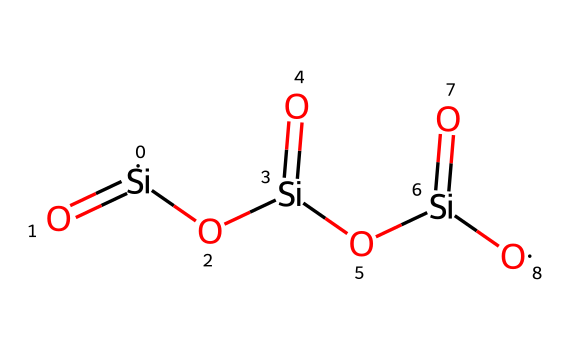What is the chemical name of this compound? The SMILES structure indicates a molecule made of silicon (Si) and oxygen (O) atoms, which corresponds to silicon dioxide, commonly known as silica.
Answer: silicon dioxide How many silicon atoms are present in the structure? Analyzing the SMILES representation, there are three silicon (Si) atoms, as indicated by the three occurrences of "[Si]".
Answer: 3 How many oxygen atoms are there in total in the molecule? By counting the oxygen (O) atoms in the SMILES representation, we find there are six occurrences of "[O]", leading to a total of six oxygen atoms.
Answer: 6 What type of bonding is present between silicon and oxygen in silicon dioxide? The structure shows double bonds between silicon and oxygen, represented as "[Si](=[O])", indicating that each silicon atom forms a double bond with each oxygen atom.
Answer: double bond Why is silicon dioxide commonly used in computer chips? Silicon dioxide provides excellent insulation and has a high dielectric strength, making it suitable for use in electronic components, which require stable insulation properties.
Answer: insulation What is the molecular formula of silicon dioxide based on the structure? The count of silicon and oxygen atoms gives the molecular formula SiO2, as there are 3 Si and 6 O atoms, showing that it is commonly represented as SiO2.
Answer: SiO2 